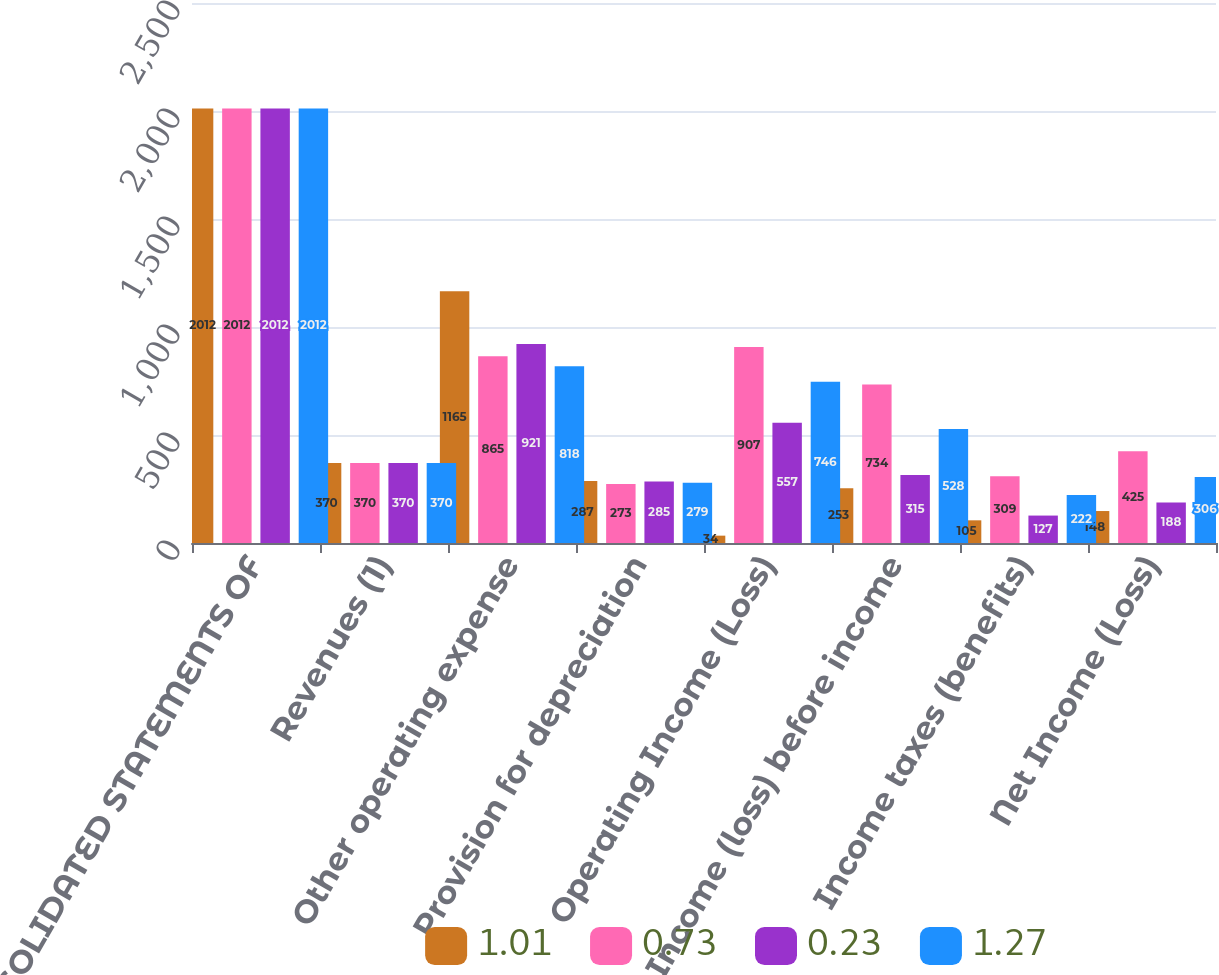Convert chart. <chart><loc_0><loc_0><loc_500><loc_500><stacked_bar_chart><ecel><fcel>CONSOLIDATED STATEMENTS OF<fcel>Revenues (1)<fcel>Other operating expense<fcel>Provision for depreciation<fcel>Operating Income (Loss)<fcel>Income (loss) before income<fcel>Income taxes (benefits)<fcel>Net Income (Loss)<nl><fcel>1.01<fcel>2012<fcel>370<fcel>1165<fcel>287<fcel>34<fcel>253<fcel>105<fcel>148<nl><fcel>0.73<fcel>2012<fcel>370<fcel>865<fcel>273<fcel>907<fcel>734<fcel>309<fcel>425<nl><fcel>0.23<fcel>2012<fcel>370<fcel>921<fcel>285<fcel>557<fcel>315<fcel>127<fcel>188<nl><fcel>1.27<fcel>2012<fcel>370<fcel>818<fcel>279<fcel>746<fcel>528<fcel>222<fcel>306<nl></chart> 